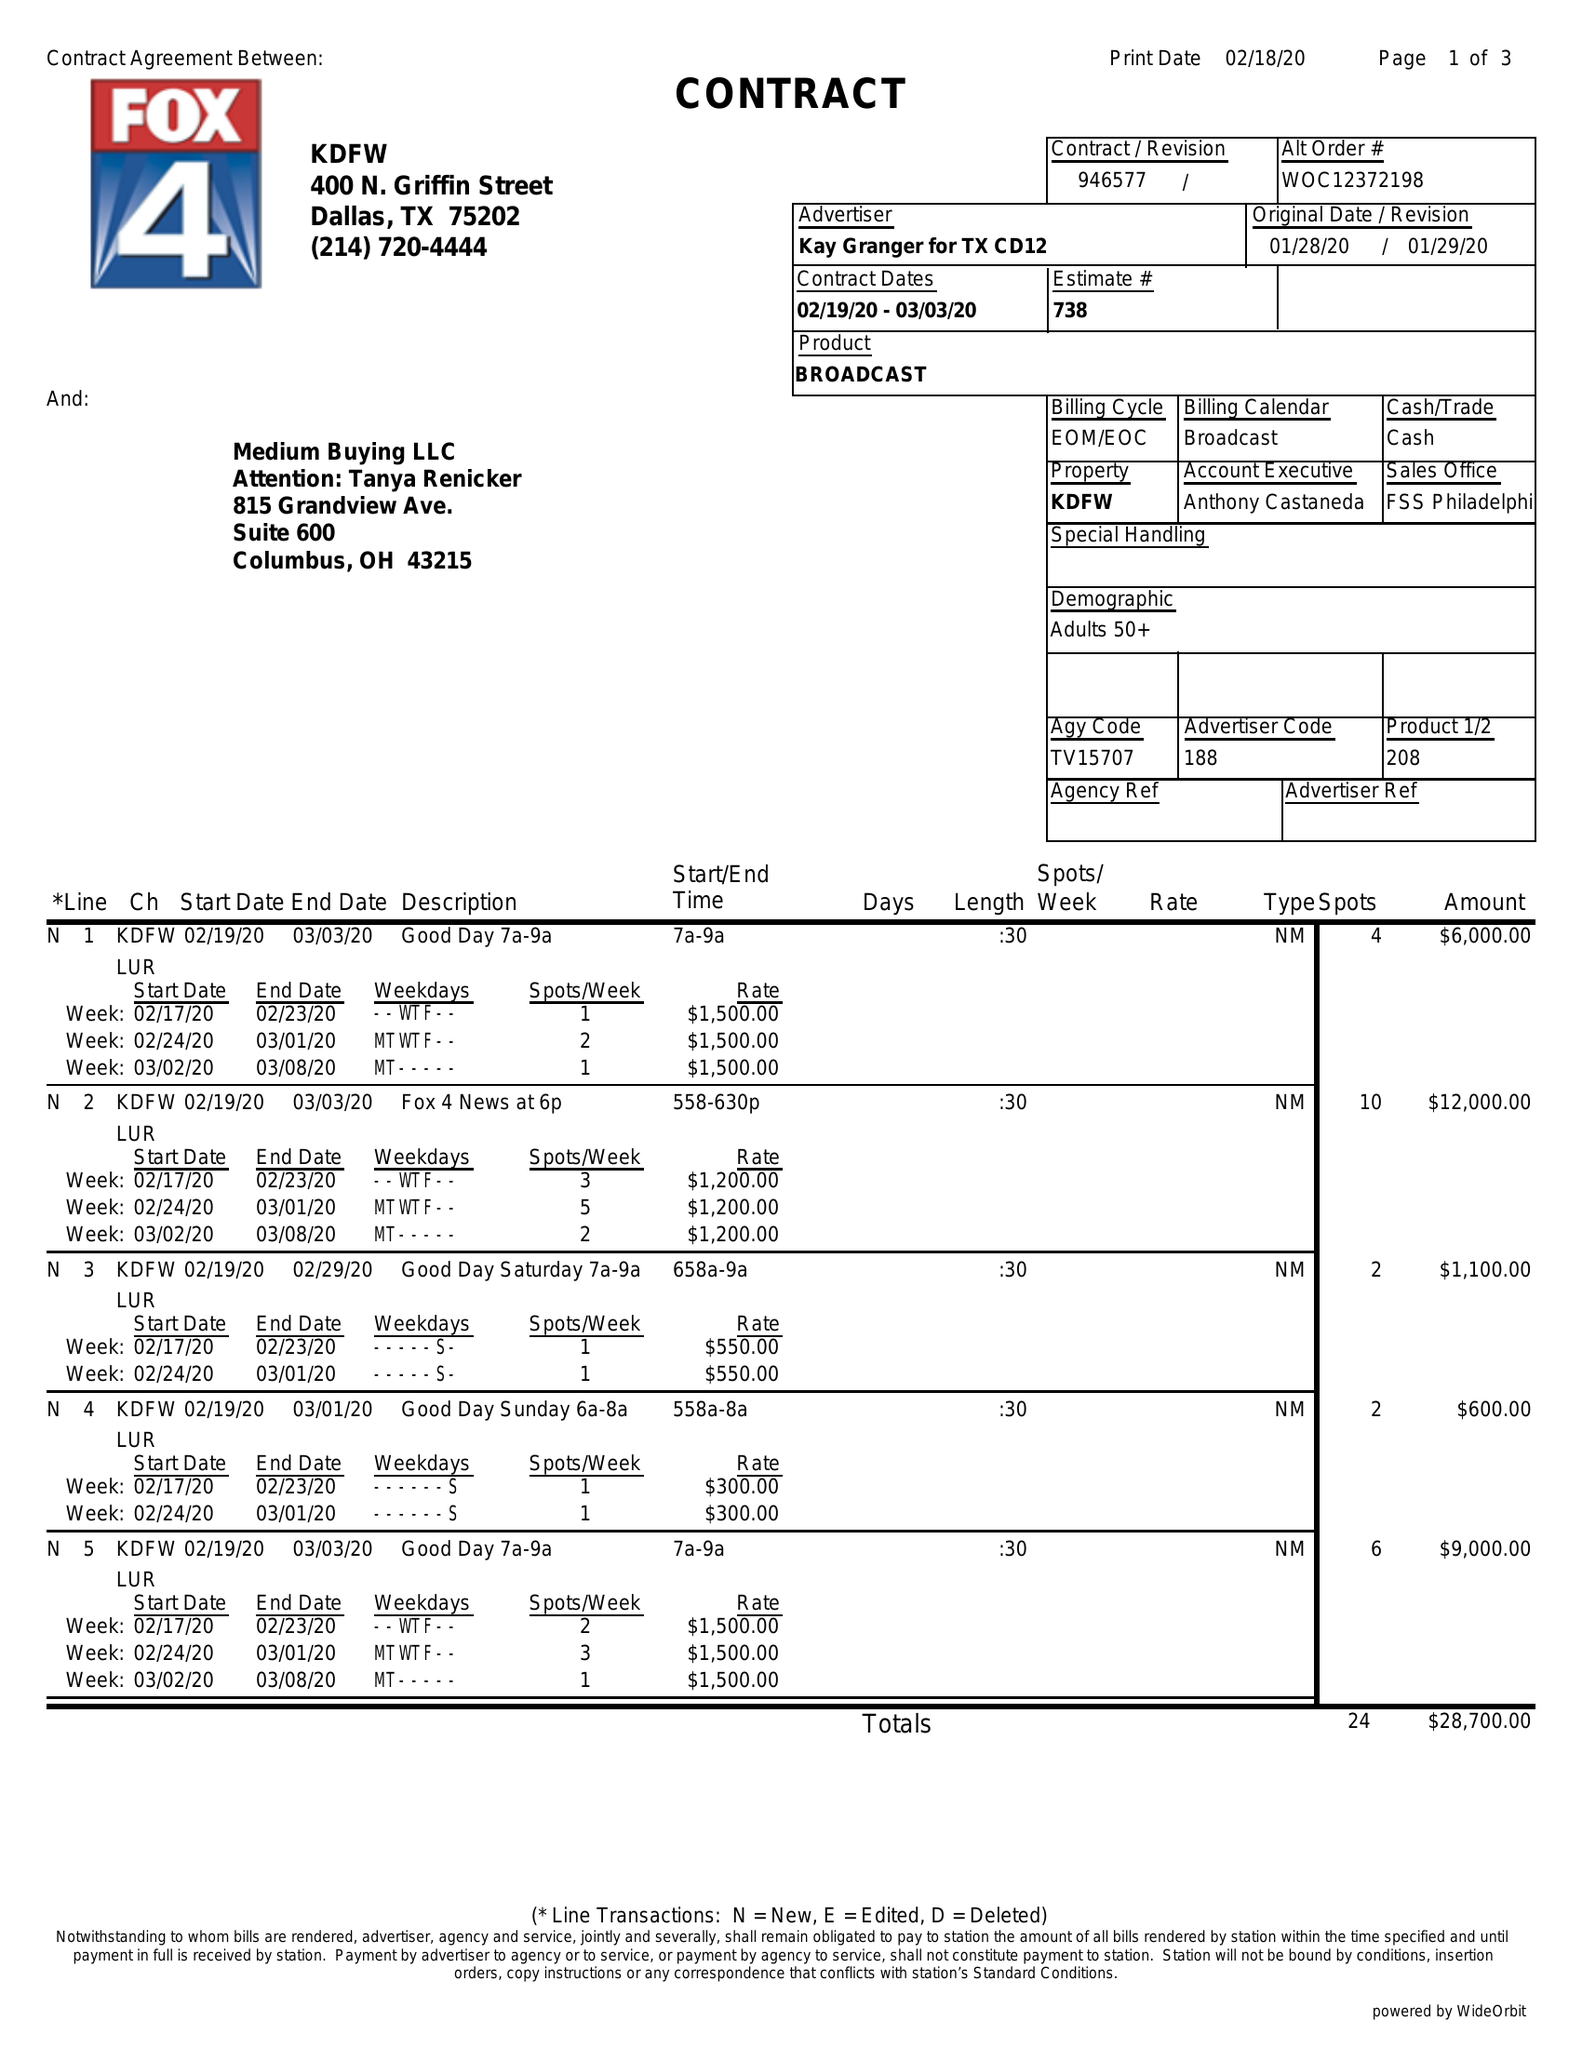What is the value for the advertiser?
Answer the question using a single word or phrase. KAY GRANGER FOR TX CD12 